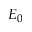Convert formula to latex. <formula><loc_0><loc_0><loc_500><loc_500>E _ { 0 }</formula> 